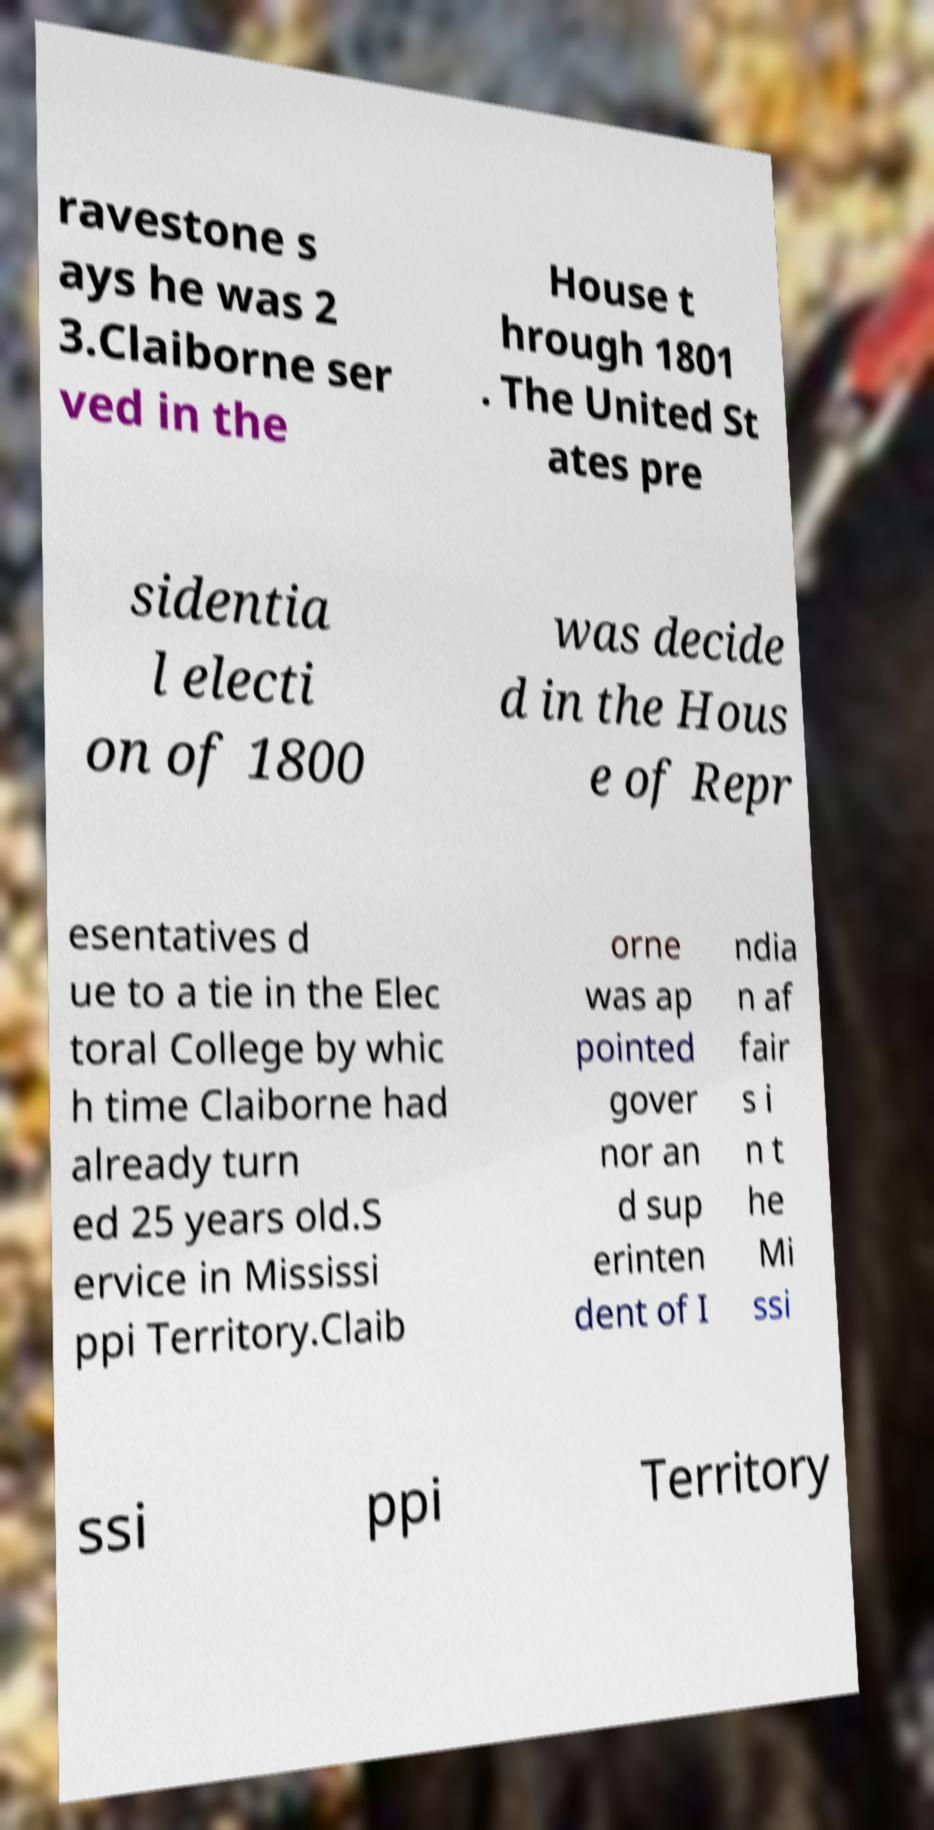Please identify and transcribe the text found in this image. ravestone s ays he was 2 3.Claiborne ser ved in the House t hrough 1801 . The United St ates pre sidentia l electi on of 1800 was decide d in the Hous e of Repr esentatives d ue to a tie in the Elec toral College by whic h time Claiborne had already turn ed 25 years old.S ervice in Mississi ppi Territory.Claib orne was ap pointed gover nor an d sup erinten dent of I ndia n af fair s i n t he Mi ssi ssi ppi Territory 